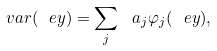Convert formula to latex. <formula><loc_0><loc_0><loc_500><loc_500>\ v a r ( \ e y ) = \sum _ { j } \ a _ { j } \varphi _ { j } ( \ e y ) ,</formula> 